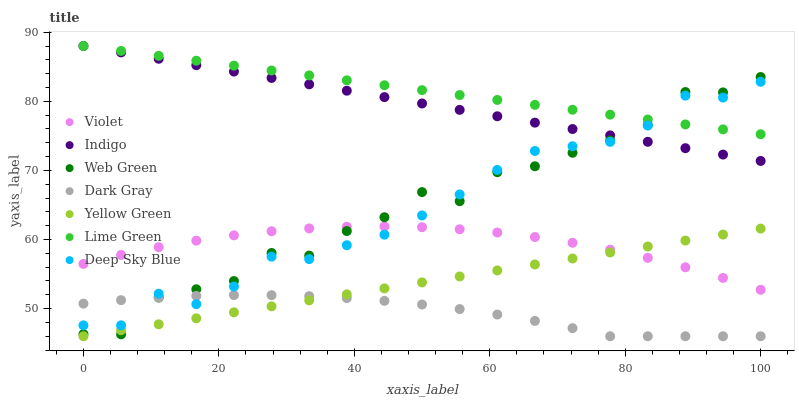Does Dark Gray have the minimum area under the curve?
Answer yes or no. Yes. Does Lime Green have the maximum area under the curve?
Answer yes or no. Yes. Does Yellow Green have the minimum area under the curve?
Answer yes or no. No. Does Yellow Green have the maximum area under the curve?
Answer yes or no. No. Is Yellow Green the smoothest?
Answer yes or no. Yes. Is Web Green the roughest?
Answer yes or no. Yes. Is Web Green the smoothest?
Answer yes or no. No. Is Yellow Green the roughest?
Answer yes or no. No. Does Yellow Green have the lowest value?
Answer yes or no. Yes. Does Web Green have the lowest value?
Answer yes or no. No. Does Lime Green have the highest value?
Answer yes or no. Yes. Does Yellow Green have the highest value?
Answer yes or no. No. Is Violet less than Indigo?
Answer yes or no. Yes. Is Indigo greater than Yellow Green?
Answer yes or no. Yes. Does Violet intersect Deep Sky Blue?
Answer yes or no. Yes. Is Violet less than Deep Sky Blue?
Answer yes or no. No. Is Violet greater than Deep Sky Blue?
Answer yes or no. No. Does Violet intersect Indigo?
Answer yes or no. No. 